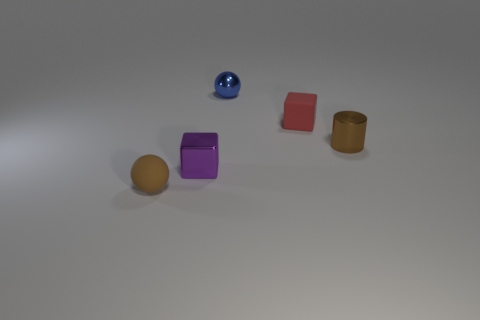Is the number of brown metal objects greater than the number of large purple shiny objects?
Provide a succinct answer. Yes. The tiny object that is behind the small brown ball and on the left side of the blue sphere is made of what material?
Keep it short and to the point. Metal. How many other objects are the same material as the blue sphere?
Make the answer very short. 2. What number of big rubber blocks are the same color as the tiny rubber ball?
Provide a succinct answer. 0. How big is the matte object that is in front of the tiny rubber object right of the small metal thing that is behind the metal cylinder?
Keep it short and to the point. Small. How many shiny objects are tiny purple blocks or tiny brown balls?
Provide a succinct answer. 1. There is a blue metal thing; does it have the same shape as the brown thing left of the purple block?
Your response must be concise. Yes. Is the number of tiny brown objects behind the tiny red object greater than the number of small matte objects behind the small blue sphere?
Offer a terse response. No. Is there anything else that has the same color as the rubber ball?
Provide a succinct answer. Yes. Is there a purple shiny thing on the right side of the tiny ball behind the small rubber thing that is in front of the red rubber thing?
Keep it short and to the point. No. 